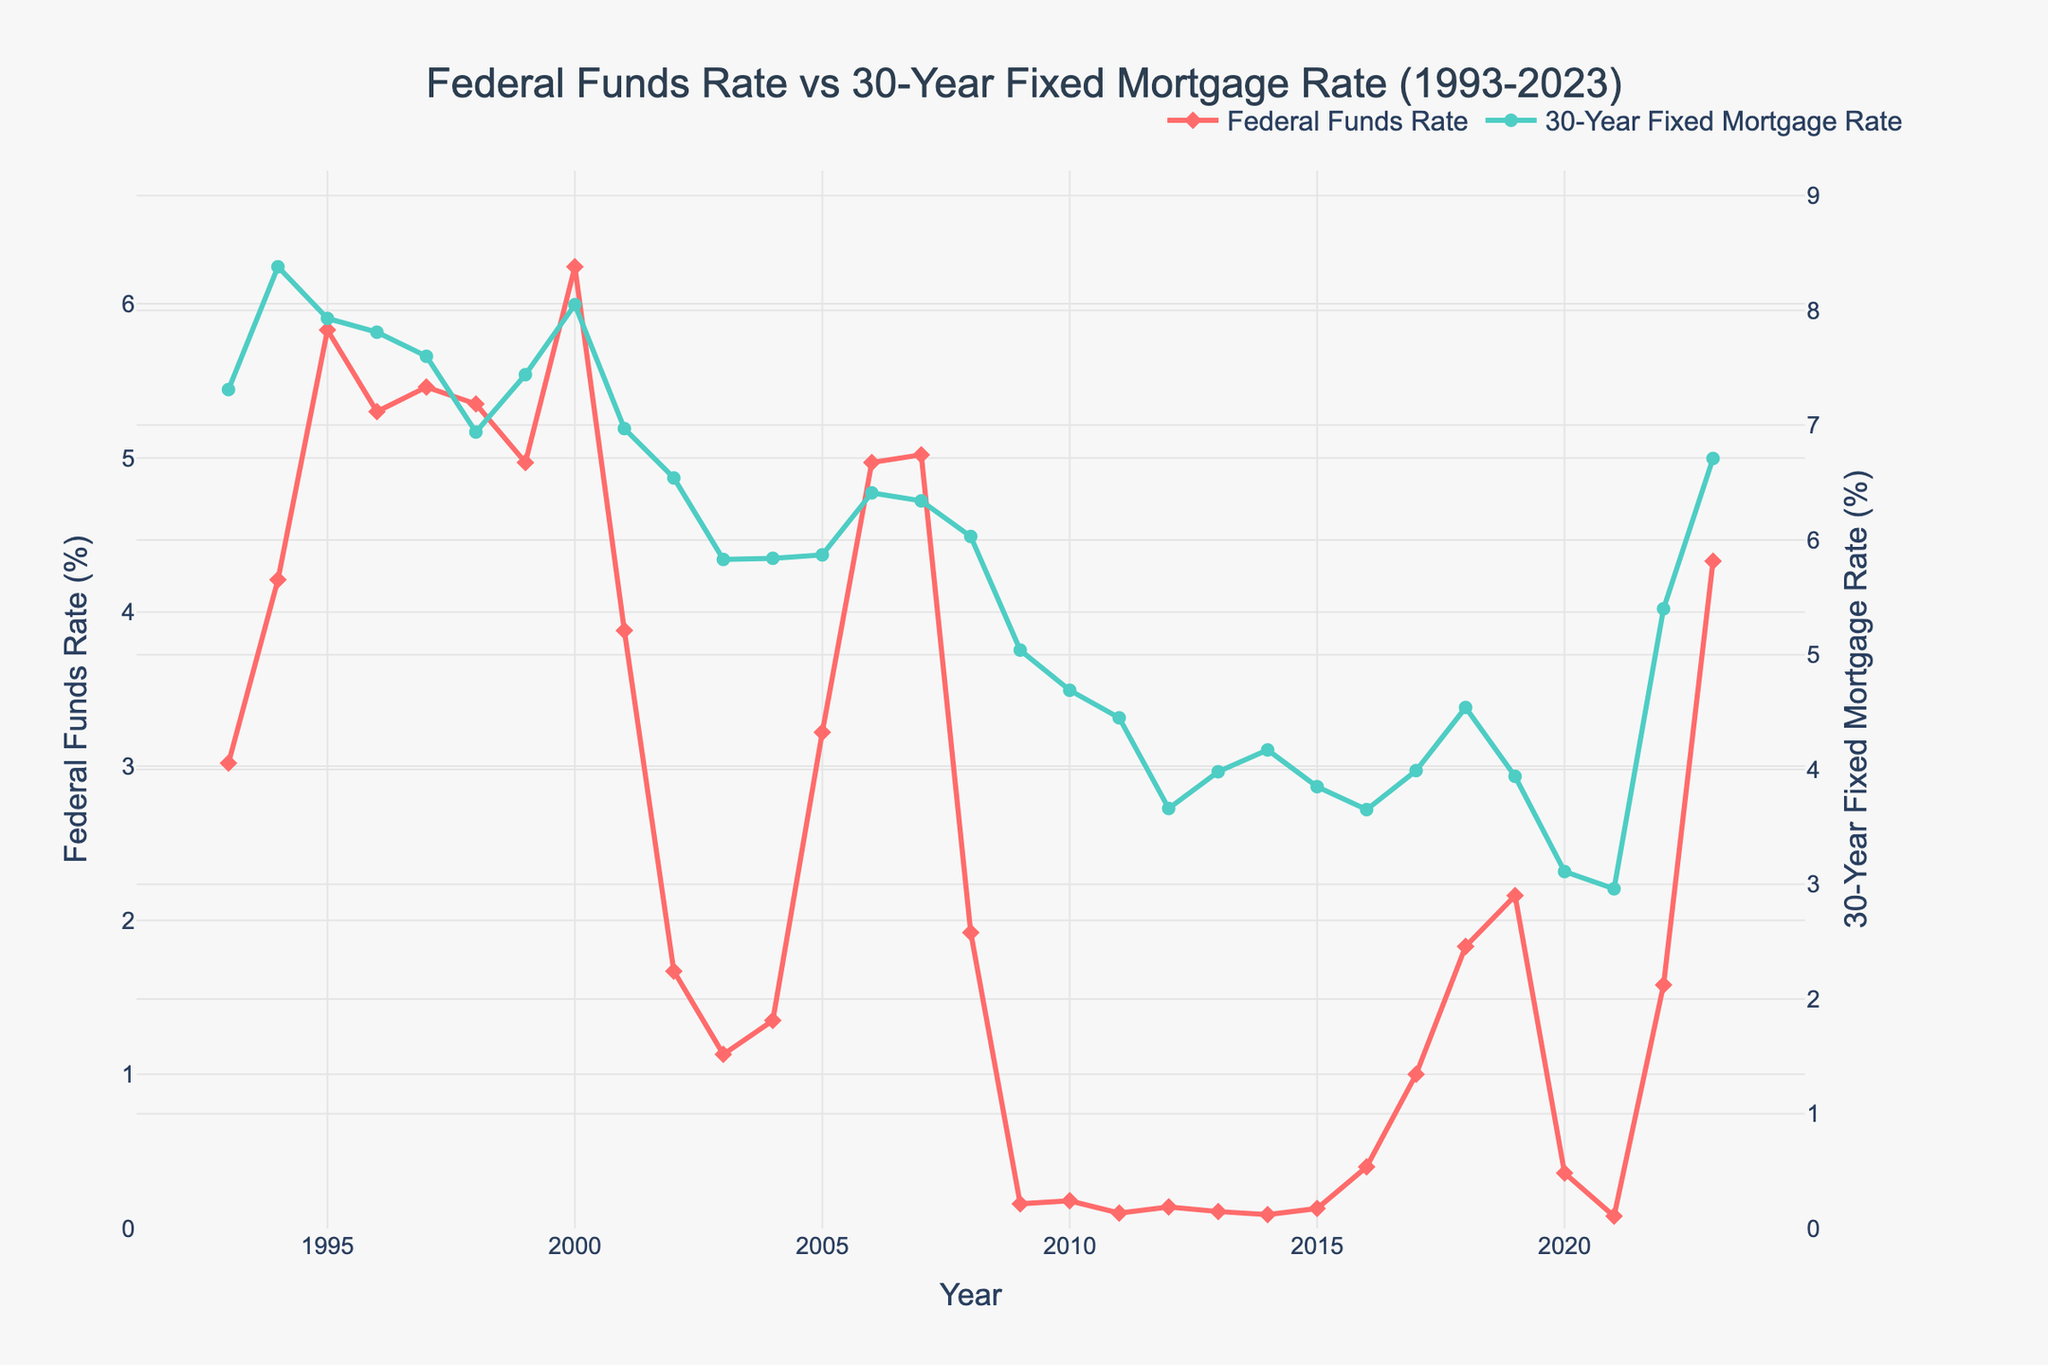What was the Federal Funds Rate in 2000 compared to 2003? In the year 2000, the Federal Funds Rate was 6.24%, while in 2003, it was 1.13%. To compare, 6.24% is significantly higher than 1.13%.
Answer: 6.24% (2000) > 1.13% (2003) During which year did the 30-Year Fixed Mortgage Rate reach its lowest point according to the chart? The lowest point for the 30-Year Fixed Mortgage Rate on the chart is in 2021, with a rate of 2.96%. By visually inspecting the line graph, we can identify this minimum value.
Answer: 2021 By how much did the Federal Funds Rate decrease from 2000 to 2003? In 2000, the Federal Funds Rate was 6.24%, and by 2003, it had decreased to 1.13%. The decrease is calculated as 6.24% - 1.13% = 5.11%.
Answer: 5.11% What is the average Federal Funds Rate over the last 30 years shown in the figure? To find the average, sum the Federal Funds Rates from 1993 to 2023 and divide by the number of years. (3.02 + 4.21 + 5.83 + 5.3 + 5.46 + 5.35 + 4.97 + 6.24 + 3.88 + 1.67 + 1.13 + 1.35 + 3.22 + 4.97 + 5.02 + 1.92 + 0.16 + 0.18 + 0.1 + 0.14 + 0.11 + 0.09 + 0.13 + 0.4 + 1 + 1.83 + 2.16 + 0.36 + 0.08 + 1.58 + 4.33) / 31 ≈ 2.56%.
Answer: 2.56% How did the mortgage rates in 2000 compare to those in 2008? In 2000, the 30-Year Fixed Mortgage Rate was 8.05%, while in 2008, it was 6.03%. Thus, the mortgage rates were higher in 2000.
Answer: 8.05% (2000) > 6.03% (2008) Which year experienced the most substantial increase in the Federal Funds Rate? Observing the chart, the most significant increase in the Federal Funds Rate appears between 2022 (1.58%) and 2023 (4.33%). The increase is calculated as 4.33% - 1.58% = 2.75%.
Answer: 2022-2023 Are there any years when the 30-Year Fixed Mortgage Rate and the Federal Funds Rate appear to move in opposite directions? Provide an example. In the year 2005, the Federal Funds Rate increased from 1.35% to 3.22%, while the 30-Year Fixed Mortgage Rate remained fairly constant, moving from 5.84% to 5.87%. This indicates the two rates did not align in their movements.
Answer: 2005 What trend do you notice in the Federal Funds Rate post-2008 financial crisis? After the 2008 financial crisis, the Federal Funds Rate dropped significantly to 0.16% in 2009 and stayed extremely low (<1%) until 2016, indicating an extended period of low rates.
Answer: Significant drop, extended period of low rates 